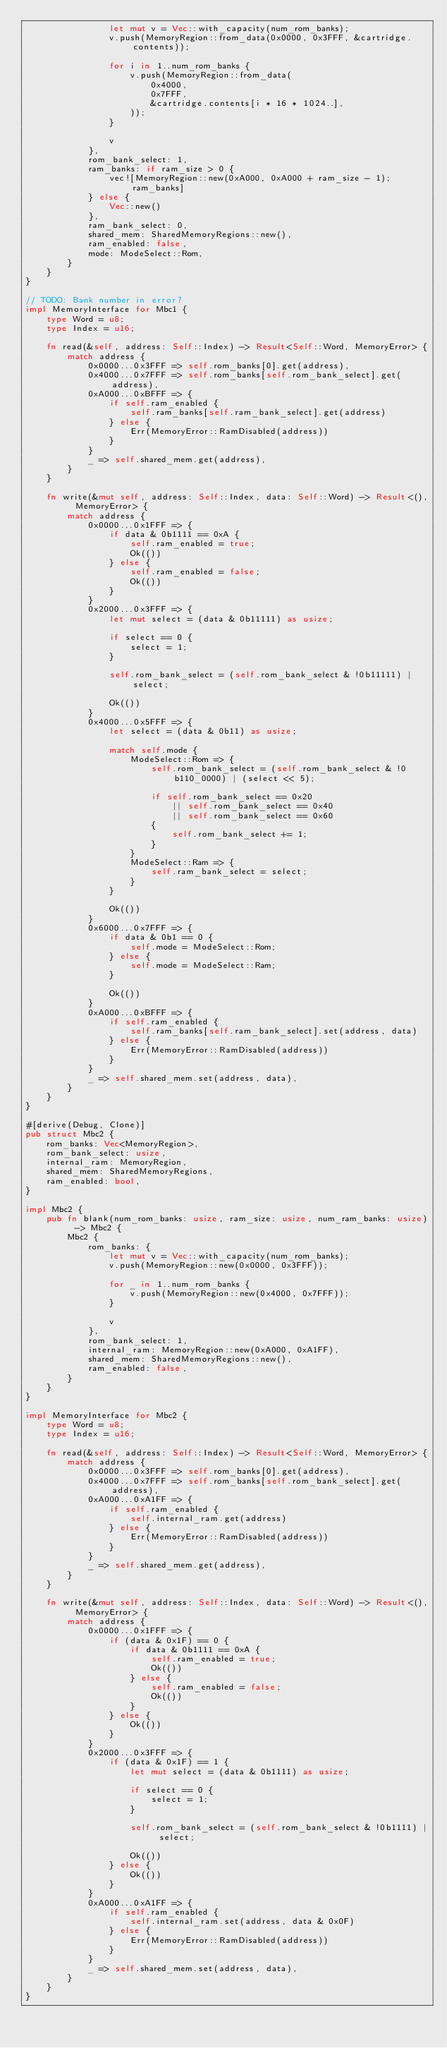Convert code to text. <code><loc_0><loc_0><loc_500><loc_500><_Rust_>                let mut v = Vec::with_capacity(num_rom_banks);
                v.push(MemoryRegion::from_data(0x0000, 0x3FFF, &cartridge.contents));

                for i in 1..num_rom_banks {
                    v.push(MemoryRegion::from_data(
                        0x4000,
                        0x7FFF,
                        &cartridge.contents[i * 16 * 1024..],
                    ));
                }

                v
            },
            rom_bank_select: 1,
            ram_banks: if ram_size > 0 {
                vec![MemoryRegion::new(0xA000, 0xA000 + ram_size - 1); ram_banks]
            } else {
                Vec::new()
            },
            ram_bank_select: 0,
            shared_mem: SharedMemoryRegions::new(),
            ram_enabled: false,
            mode: ModeSelect::Rom,
        }
    }
}

// TODO: Bank number in error?
impl MemoryInterface for Mbc1 {
    type Word = u8;
    type Index = u16;

    fn read(&self, address: Self::Index) -> Result<Self::Word, MemoryError> {
        match address {
            0x0000...0x3FFF => self.rom_banks[0].get(address),
            0x4000...0x7FFF => self.rom_banks[self.rom_bank_select].get(address),
            0xA000...0xBFFF => {
                if self.ram_enabled {
                    self.ram_banks[self.ram_bank_select].get(address)
                } else {
                    Err(MemoryError::RamDisabled(address))
                }
            }
            _ => self.shared_mem.get(address),
        }
    }

    fn write(&mut self, address: Self::Index, data: Self::Word) -> Result<(), MemoryError> {
        match address {
            0x0000...0x1FFF => {
                if data & 0b1111 == 0xA {
                    self.ram_enabled = true;
                    Ok(())
                } else {
                    self.ram_enabled = false;
                    Ok(())
                }
            }
            0x2000...0x3FFF => {
                let mut select = (data & 0b11111) as usize;

                if select == 0 {
                    select = 1;
                }

                self.rom_bank_select = (self.rom_bank_select & !0b11111) | select;

                Ok(())
            }
            0x4000...0x5FFF => {
                let select = (data & 0b11) as usize;

                match self.mode {
                    ModeSelect::Rom => {
                        self.rom_bank_select = (self.rom_bank_select & !0b110_0000) | (select << 5);

                        if self.rom_bank_select == 0x20
                            || self.rom_bank_select == 0x40
                            || self.rom_bank_select == 0x60
                        {
                            self.rom_bank_select += 1;
                        }
                    }
                    ModeSelect::Ram => {
                        self.ram_bank_select = select;
                    }
                }

                Ok(())
            }
            0x6000...0x7FFF => {
                if data & 0b1 == 0 {
                    self.mode = ModeSelect::Rom;
                } else {
                    self.mode = ModeSelect::Ram;
                }

                Ok(())
            }
            0xA000...0xBFFF => {
                if self.ram_enabled {
                    self.ram_banks[self.ram_bank_select].set(address, data)
                } else {
                    Err(MemoryError::RamDisabled(address))
                }
            }
            _ => self.shared_mem.set(address, data),
        }
    }
}

#[derive(Debug, Clone)]
pub struct Mbc2 {
    rom_banks: Vec<MemoryRegion>,
    rom_bank_select: usize,
    internal_ram: MemoryRegion,
    shared_mem: SharedMemoryRegions,
    ram_enabled: bool,
}

impl Mbc2 {
    pub fn blank(num_rom_banks: usize, ram_size: usize, num_ram_banks: usize) -> Mbc2 {
        Mbc2 {
            rom_banks: {
                let mut v = Vec::with_capacity(num_rom_banks);
                v.push(MemoryRegion::new(0x0000, 0x3FFF));

                for _ in 1..num_rom_banks {
                    v.push(MemoryRegion::new(0x4000, 0x7FFF));
                }

                v
            },
            rom_bank_select: 1,
            internal_ram: MemoryRegion::new(0xA000, 0xA1FF),
            shared_mem: SharedMemoryRegions::new(),
            ram_enabled: false,
        }
    }
}

impl MemoryInterface for Mbc2 {
    type Word = u8;
    type Index = u16;

    fn read(&self, address: Self::Index) -> Result<Self::Word, MemoryError> {
        match address {
            0x0000...0x3FFF => self.rom_banks[0].get(address),
            0x4000...0x7FFF => self.rom_banks[self.rom_bank_select].get(address),
            0xA000...0xA1FF => {
                if self.ram_enabled {
                    self.internal_ram.get(address)
                } else {
                    Err(MemoryError::RamDisabled(address))
                }
            }
            _ => self.shared_mem.get(address),
        }
    }

    fn write(&mut self, address: Self::Index, data: Self::Word) -> Result<(), MemoryError> {
        match address {
            0x0000...0x1FFF => {
                if (data & 0x1F) == 0 {
                    if data & 0b1111 == 0xA {
                        self.ram_enabled = true;
                        Ok(())
                    } else {
                        self.ram_enabled = false;
                        Ok(())
                    }
                } else {
                    Ok(())
                }
            }
            0x2000...0x3FFF => {
                if (data & 0x1F) == 1 {
                    let mut select = (data & 0b1111) as usize;

                    if select == 0 {
                        select = 1;
                    }

                    self.rom_bank_select = (self.rom_bank_select & !0b1111) | select;

                    Ok(())
                } else {
                    Ok(())
                }
            }
            0xA000...0xA1FF => {
                if self.ram_enabled {
                    self.internal_ram.set(address, data & 0x0F)
                } else {
                    Err(MemoryError::RamDisabled(address))
                }
            }
            _ => self.shared_mem.set(address, data),
        }
    }
}
</code> 